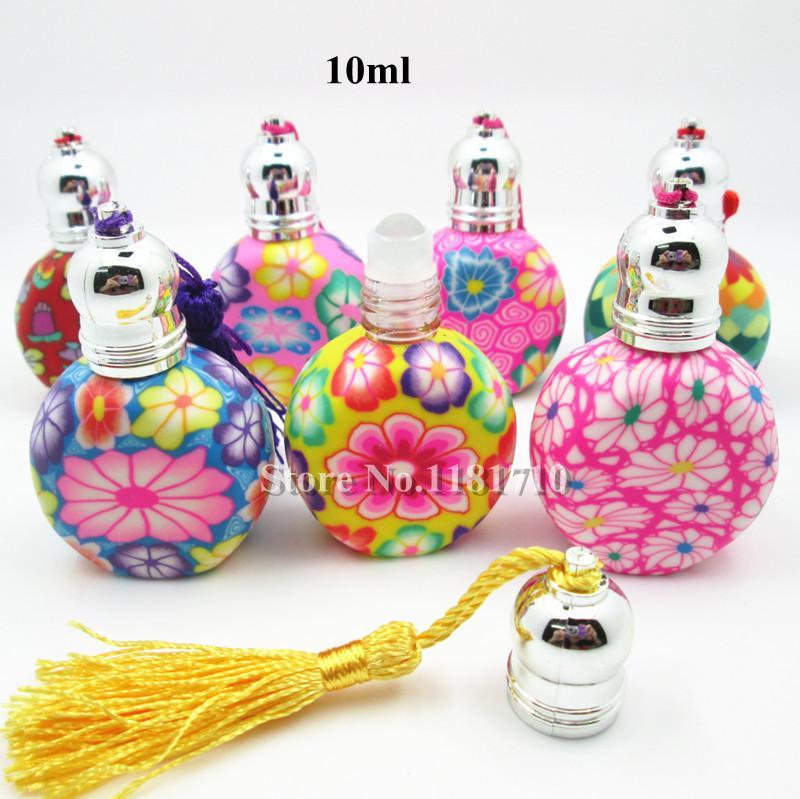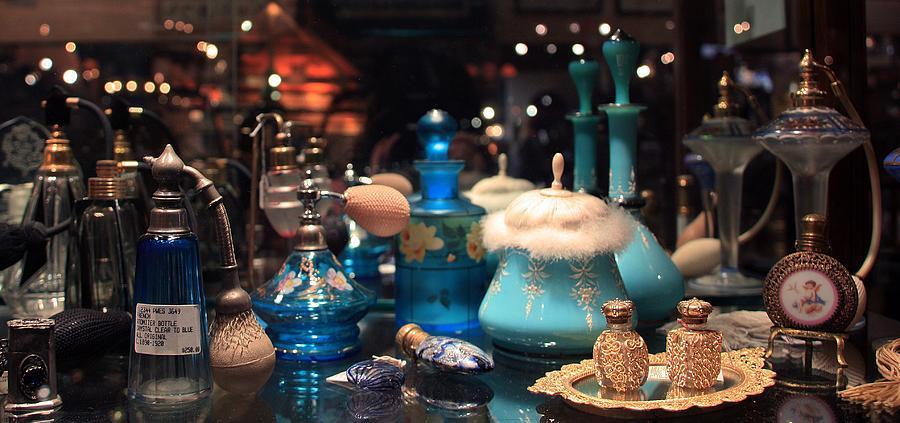The first image is the image on the left, the second image is the image on the right. For the images displayed, is the sentence "An image includes fragrance bottles sitting on a round mirrored tray with scalloped edges." factually correct? Answer yes or no. Yes. The first image is the image on the left, the second image is the image on the right. For the images shown, is this caption "At least one image is less than four fragrances." true? Answer yes or no. No. 